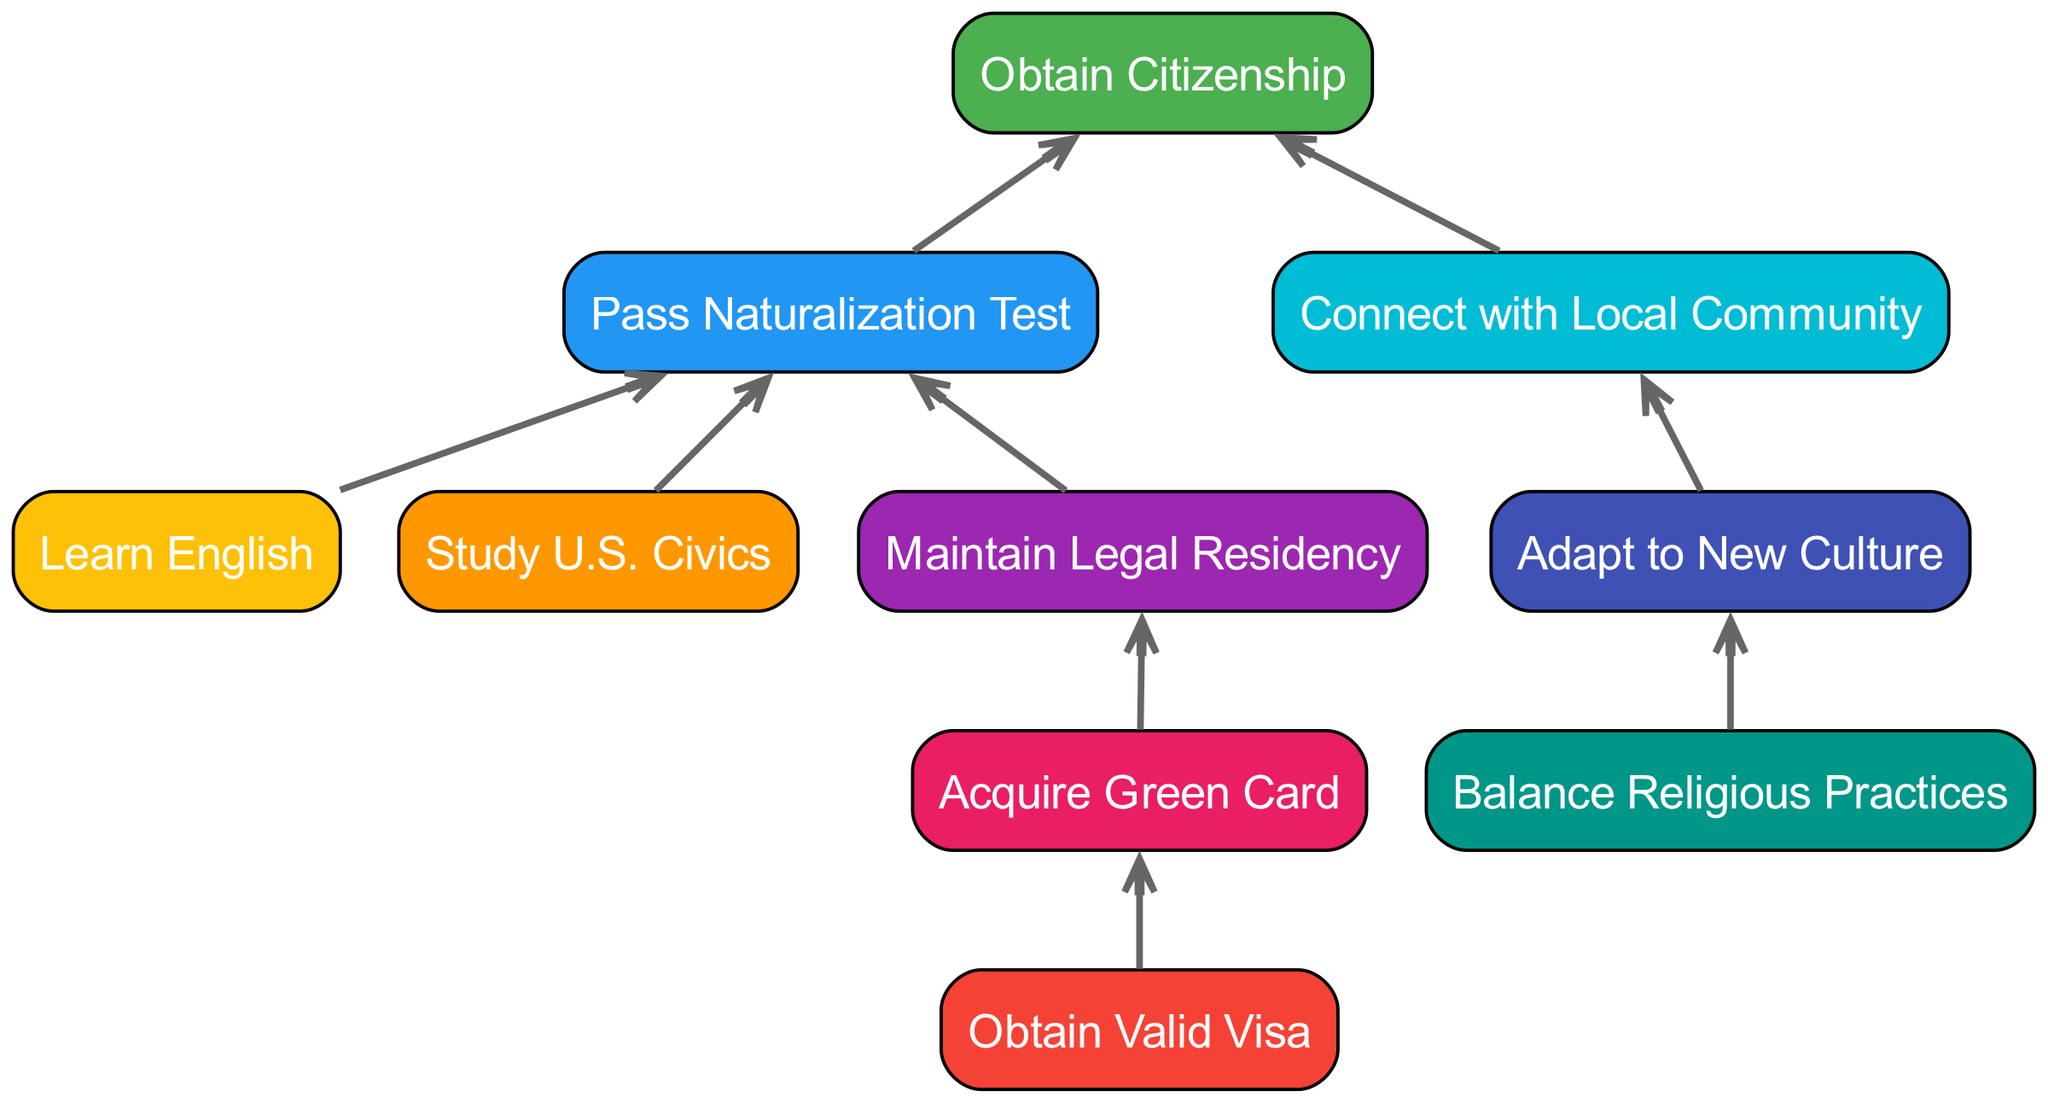What is the final step to obtain citizenship? The diagram indicates that the final step to obtaining citizenship is "Obtain Citizenship," which is connected to the "Naturalization" step.
Answer: Obtain Citizenship How many steps are needed before reaching naturalization? To reach "Naturalization," three steps must be completed: "Language," "Civics," and "Residency." These are all prerequisites that connect to the "Naturalization" node.
Answer: Three What step comes after acquiring a green card? According to the connections in the diagram, "Maintain Legal Residency" follows after "Acquire Green Card." This is the next step in the process.
Answer: Maintain Legal Residency From which step do you start the citizenship process? The process begins with "Obtain Valid Visa," as indicated by the connection leading to "Acquire Green Card." This is the first step needed for obtaining citizenship.
Answer: Obtain Valid Visa What is the relationship between community and citizenship in the flow? The diagram shows that "Connect with Local Community" leads to "Obtain Citizenship," highlighting that involvement in the local community is a prerequisite for citizenship.
Answer: Connect with Local Community Which two nodes are prerequisites for the naturalization test? The prerequisites for the "Naturalization Test" are "Learn English" and "Study U.S. Civics," as both are necessary for passing the test as indicated in the diagram.
Answer: Learn English, Study U.S. Civics How many nodes are connected directly to the adaptation step? There are two nodes connected directly to "Adapt to New Culture": "Balance Religious Practices" and "Connect with Local Community." This signifies the importance of adaptation in the overall process.
Answer: Two Which step is necessary before applying for a green card? Before applying for a green card, one must "Obtain Valid Visa," as shown by the connection leading to "Acquire Green Card." This is the essential initial step.
Answer: Obtain Valid Visa What is the significance of balancing religious practices in this diagram? "Balance Religious Practices" is connected to "Adapt to New Culture," implying it's essential for successful integration into the new country and contributes to cultural adaptation.
Answer: Adapt to New Culture 